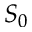Convert formula to latex. <formula><loc_0><loc_0><loc_500><loc_500>S _ { 0 }</formula> 